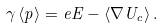<formula> <loc_0><loc_0><loc_500><loc_500>\gamma \, \langle { p } \rangle = e { E } - \langle \nabla U _ { c } \rangle \, .</formula> 